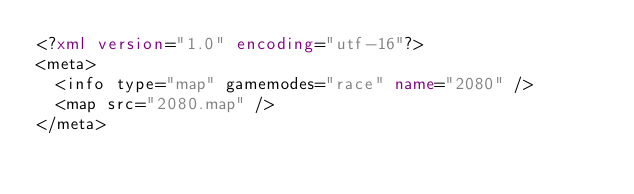Convert code to text. <code><loc_0><loc_0><loc_500><loc_500><_XML_><?xml version="1.0" encoding="utf-16"?>
<meta>
  <info type="map" gamemodes="race" name="2080" />
  <map src="2080.map" />
</meta></code> 